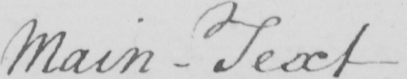Transcribe the text shown in this historical manuscript line. Main - Text 